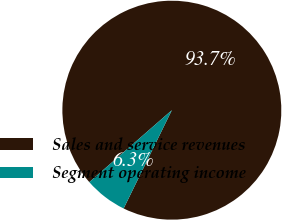<chart> <loc_0><loc_0><loc_500><loc_500><pie_chart><fcel>Sales and service revenues<fcel>Segment operating income<nl><fcel>93.67%<fcel>6.33%<nl></chart> 